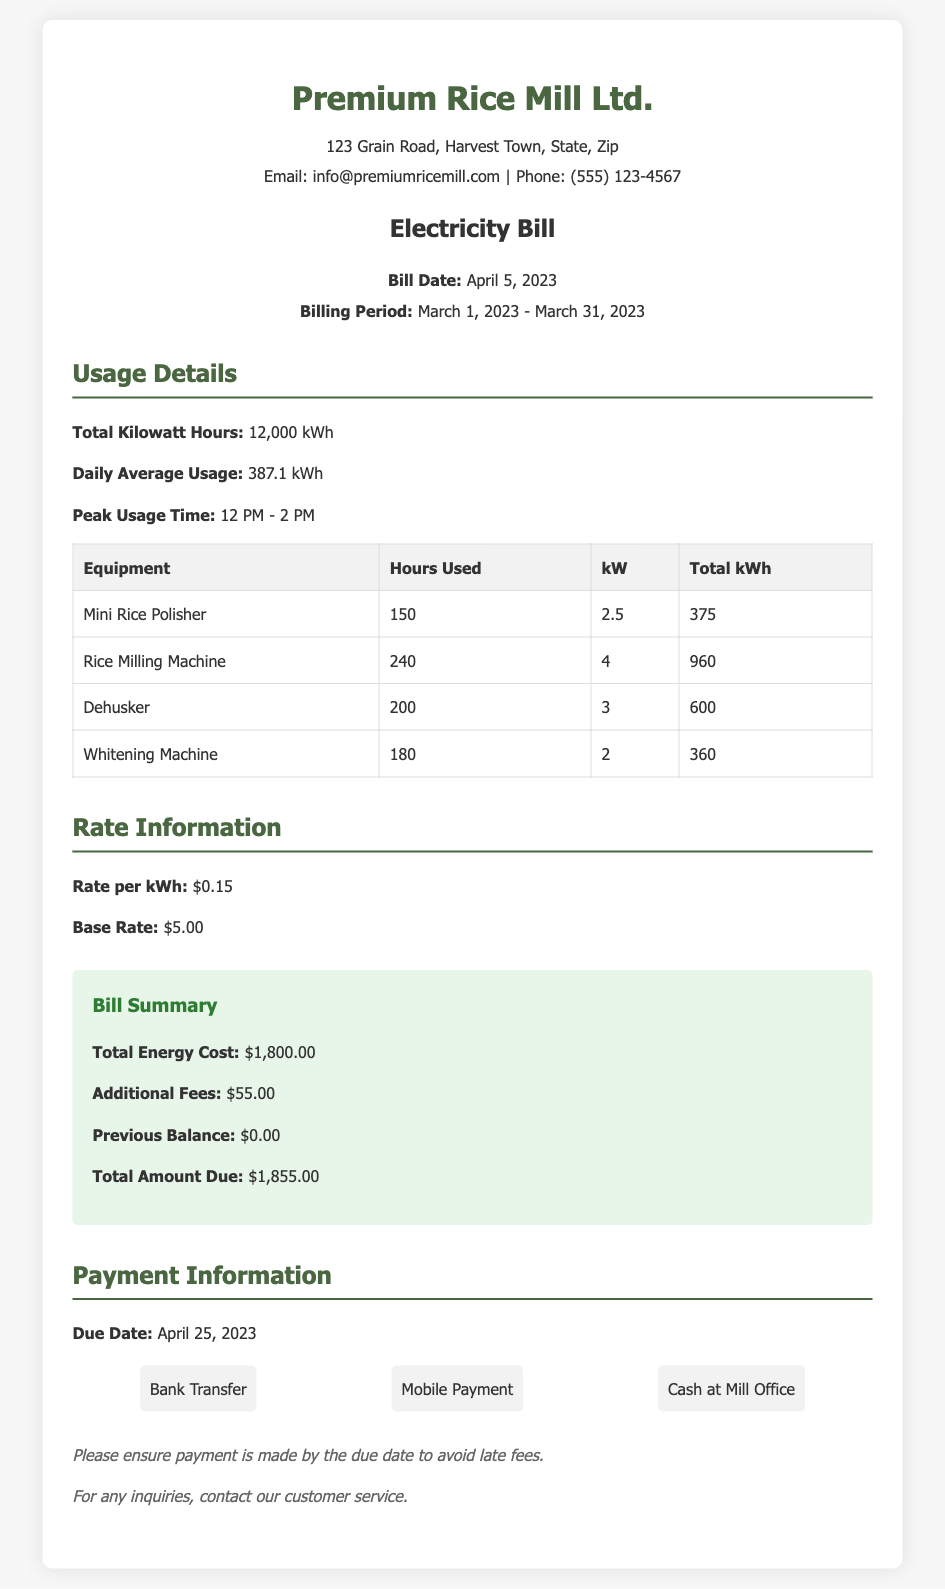What is the total kilowatt hours consumed? The total kilowatt hours consumed is stated directly in the usage details section.
Answer: 12,000 kWh What is the rate per kilowatt hour? The rate per kilowatt hour is highlighted in the rate information section of the document.
Answer: $0.15 What is the billing period? The billing period is outlined clearly in the header section of the document.
Answer: March 1, 2023 - March 31, 2023 What is the total amount due? The total amount due is found in the bill summary section of the document.
Answer: $1,855.00 How many hours was the rice milling machine used? The hours used for the rice milling machine is detailed in the usage details table.
Answer: 240 What is the base rate? The base rate can be found in the rate information section of the document.
Answer: $5.00 During which time was peak usage observed? The peak usage time is specified in the usage details section for clarity.
Answer: 12 PM - 2 PM What are the payment methods available? The available payment methods are listed in the payment information section of the document.
Answer: Bank Transfer, Mobile Payment, Cash at Mill Office What is the due date for payment? The due date is mentioned clearly in the payment information section of the document.
Answer: April 25, 2023 